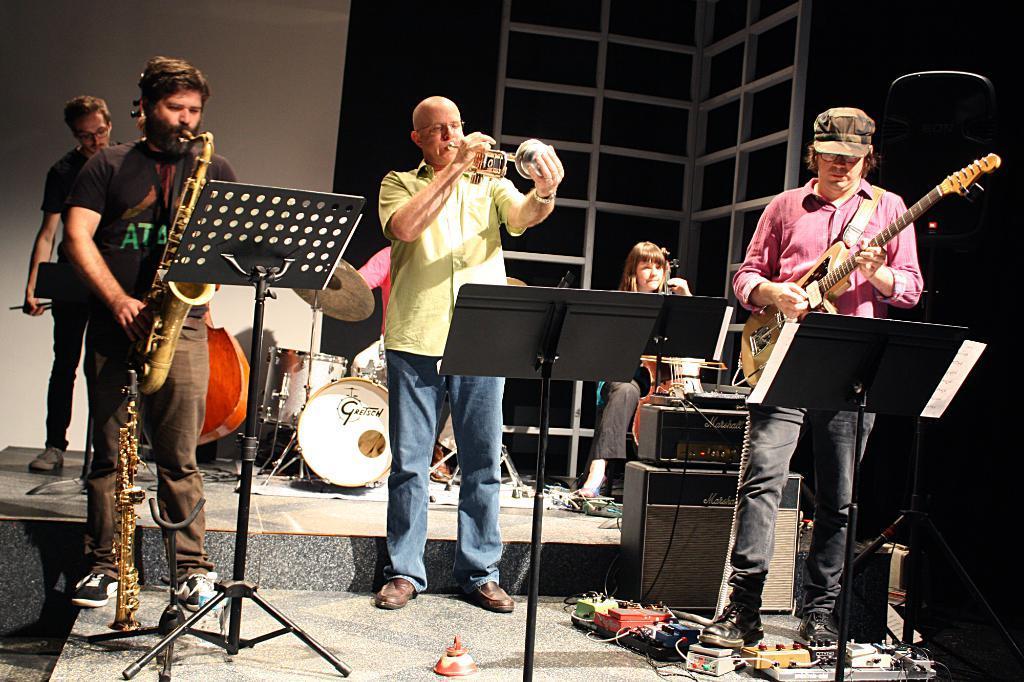Can you describe this image briefly? In this image i can see few people holding musical instruments in their hands, and in the background i can see few people, few musical instruments and a wall. 